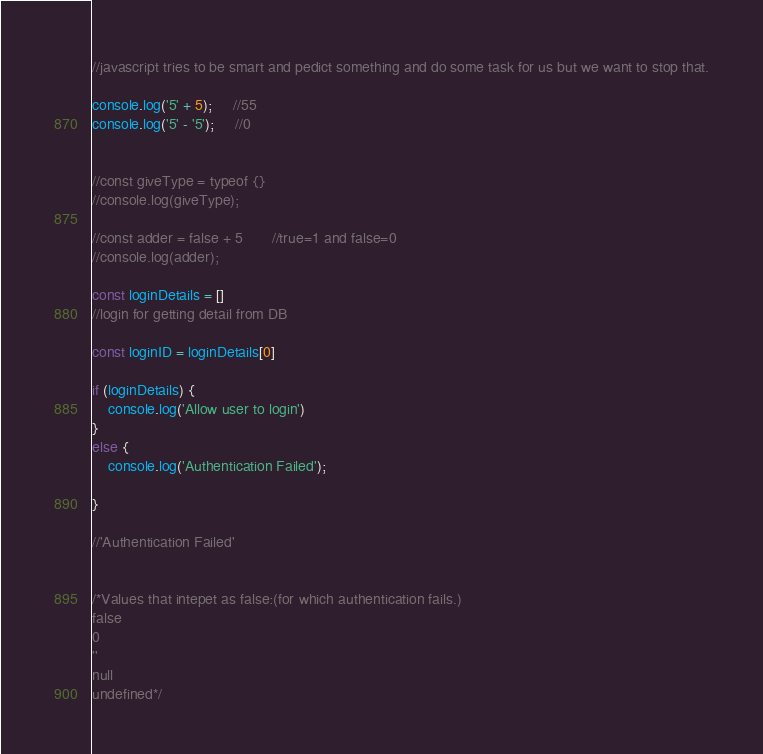Convert code to text. <code><loc_0><loc_0><loc_500><loc_500><_JavaScript_>//javascript tries to be smart and pedict something and do some task for us but we want to stop that.

console.log('5' + 5);     //55
console.log('5' - '5');     //0


//const giveType = typeof {}
//console.log(giveType);

//const adder = false + 5       //true=1 and false=0
//console.log(adder);

const loginDetails = []
//login for getting detail from DB

const loginID = loginDetails[0]

if (loginDetails) {
    console.log('Allow user to login')
}
else {
    console.log('Authentication Failed');

}

//'Authentication Failed'


/*Values that intepet as false:(for which authentication fails.)
false
0
''
null
undefined*/




</code> 